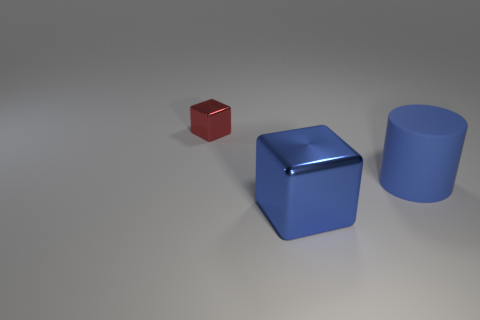The cube behind the large blue thing in front of the blue thing to the right of the big cube is what color?
Your response must be concise. Red. How many blue things are either tiny things or matte things?
Give a very brief answer. 1. How many other small metal objects have the same shape as the blue metal object?
Your response must be concise. 1. There is a blue matte thing that is the same size as the blue cube; what is its shape?
Give a very brief answer. Cylinder. Are there any cubes behind the big rubber cylinder?
Offer a terse response. Yes. There is a blue object on the right side of the blue metallic object; are there any big blue things on the left side of it?
Provide a succinct answer. Yes. Is the number of small red shiny objects that are in front of the large cylinder less than the number of red objects that are on the left side of the big shiny block?
Keep it short and to the point. Yes. Is there anything else that is the same size as the red shiny object?
Your response must be concise. No. There is a small shiny thing; what shape is it?
Provide a succinct answer. Cube. There is a block to the right of the red metal object; what material is it?
Keep it short and to the point. Metal. 